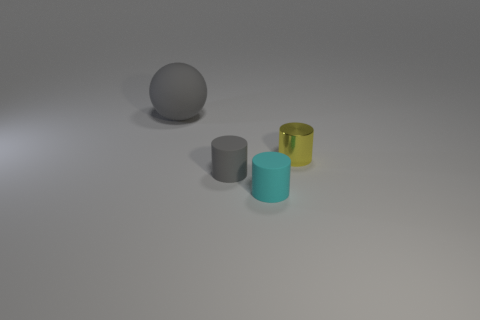There is a cylinder that is to the right of the cyan rubber cylinder; what is its material?
Provide a short and direct response. Metal. How many small objects are either gray rubber cylinders or cyan matte blocks?
Your answer should be compact. 1. What color is the rubber sphere?
Ensure brevity in your answer.  Gray. There is a rubber thing behind the small gray rubber cylinder; is there a small cyan matte cylinder behind it?
Your answer should be compact. No. Are there fewer rubber cylinders that are behind the tiny gray rubber cylinder than yellow cylinders?
Keep it short and to the point. Yes. Does the tiny thing to the right of the cyan cylinder have the same material as the cyan thing?
Offer a very short reply. No. There is a big thing that is the same material as the small gray cylinder; what color is it?
Keep it short and to the point. Gray. Are there fewer cylinders behind the tiny gray rubber cylinder than tiny matte things in front of the big rubber thing?
Your answer should be very brief. Yes. Is the color of the matte thing behind the yellow thing the same as the rubber cylinder that is behind the tiny cyan rubber cylinder?
Ensure brevity in your answer.  Yes. Is there a big ball made of the same material as the small gray cylinder?
Your answer should be compact. Yes. 